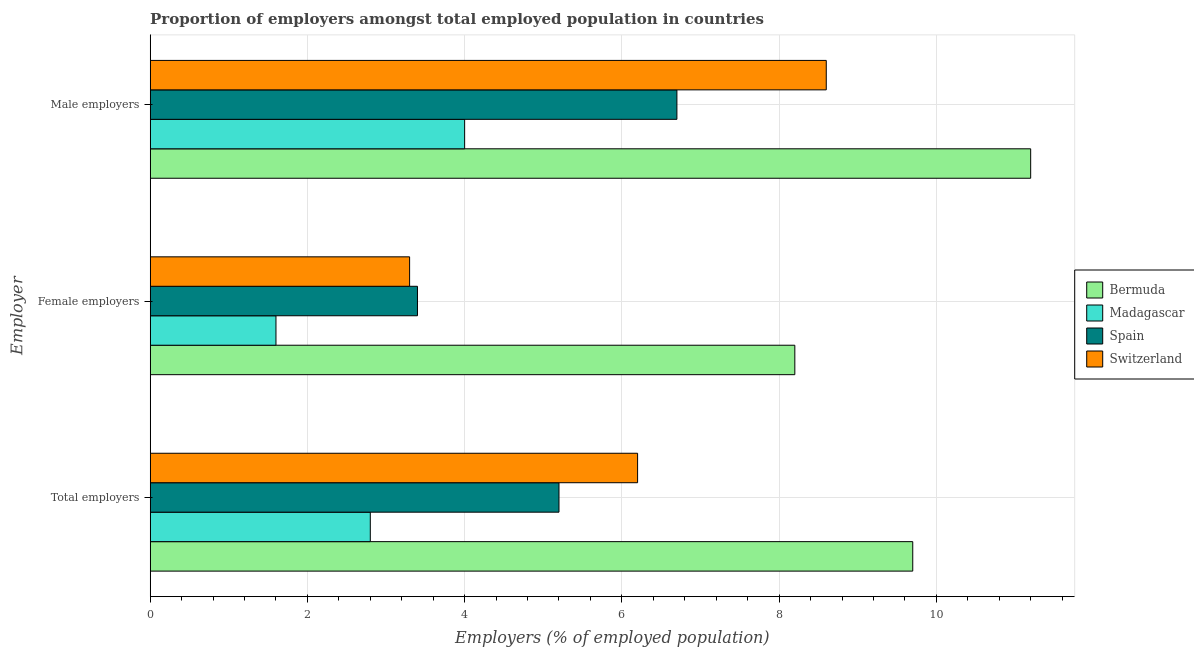How many different coloured bars are there?
Offer a very short reply. 4. How many groups of bars are there?
Provide a short and direct response. 3. Are the number of bars per tick equal to the number of legend labels?
Offer a very short reply. Yes. What is the label of the 1st group of bars from the top?
Keep it short and to the point. Male employers. What is the percentage of female employers in Switzerland?
Make the answer very short. 3.3. Across all countries, what is the maximum percentage of total employers?
Keep it short and to the point. 9.7. In which country was the percentage of total employers maximum?
Offer a very short reply. Bermuda. In which country was the percentage of total employers minimum?
Ensure brevity in your answer.  Madagascar. What is the total percentage of total employers in the graph?
Keep it short and to the point. 23.9. What is the difference between the percentage of male employers in Madagascar and that in Spain?
Keep it short and to the point. -2.7. What is the difference between the percentage of female employers in Bermuda and the percentage of male employers in Spain?
Offer a terse response. 1.5. What is the average percentage of female employers per country?
Your answer should be compact. 4.12. What is the difference between the percentage of female employers and percentage of male employers in Spain?
Ensure brevity in your answer.  -3.3. In how many countries, is the percentage of total employers greater than 4 %?
Keep it short and to the point. 3. What is the ratio of the percentage of total employers in Bermuda to that in Spain?
Make the answer very short. 1.87. Is the difference between the percentage of female employers in Switzerland and Madagascar greater than the difference between the percentage of total employers in Switzerland and Madagascar?
Offer a very short reply. No. What is the difference between the highest and the second highest percentage of female employers?
Your answer should be compact. 4.8. What is the difference between the highest and the lowest percentage of male employers?
Make the answer very short. 7.2. Is the sum of the percentage of total employers in Spain and Madagascar greater than the maximum percentage of male employers across all countries?
Offer a very short reply. No. What does the 1st bar from the top in Male employers represents?
Your answer should be compact. Switzerland. What does the 4th bar from the bottom in Male employers represents?
Offer a very short reply. Switzerland. How many bars are there?
Your response must be concise. 12. What is the difference between two consecutive major ticks on the X-axis?
Give a very brief answer. 2. Are the values on the major ticks of X-axis written in scientific E-notation?
Offer a terse response. No. Does the graph contain any zero values?
Give a very brief answer. No. Where does the legend appear in the graph?
Your answer should be compact. Center right. How many legend labels are there?
Provide a short and direct response. 4. How are the legend labels stacked?
Ensure brevity in your answer.  Vertical. What is the title of the graph?
Provide a short and direct response. Proportion of employers amongst total employed population in countries. Does "France" appear as one of the legend labels in the graph?
Offer a terse response. No. What is the label or title of the X-axis?
Provide a short and direct response. Employers (% of employed population). What is the label or title of the Y-axis?
Provide a succinct answer. Employer. What is the Employers (% of employed population) in Bermuda in Total employers?
Your response must be concise. 9.7. What is the Employers (% of employed population) in Madagascar in Total employers?
Your answer should be compact. 2.8. What is the Employers (% of employed population) in Spain in Total employers?
Your answer should be compact. 5.2. What is the Employers (% of employed population) of Switzerland in Total employers?
Provide a short and direct response. 6.2. What is the Employers (% of employed population) in Bermuda in Female employers?
Offer a very short reply. 8.2. What is the Employers (% of employed population) in Madagascar in Female employers?
Your response must be concise. 1.6. What is the Employers (% of employed population) of Spain in Female employers?
Provide a succinct answer. 3.4. What is the Employers (% of employed population) of Switzerland in Female employers?
Offer a terse response. 3.3. What is the Employers (% of employed population) of Bermuda in Male employers?
Make the answer very short. 11.2. What is the Employers (% of employed population) of Spain in Male employers?
Ensure brevity in your answer.  6.7. What is the Employers (% of employed population) of Switzerland in Male employers?
Your answer should be compact. 8.6. Across all Employer, what is the maximum Employers (% of employed population) of Bermuda?
Provide a short and direct response. 11.2. Across all Employer, what is the maximum Employers (% of employed population) of Spain?
Your answer should be very brief. 6.7. Across all Employer, what is the maximum Employers (% of employed population) in Switzerland?
Your answer should be compact. 8.6. Across all Employer, what is the minimum Employers (% of employed population) of Bermuda?
Offer a terse response. 8.2. Across all Employer, what is the minimum Employers (% of employed population) of Madagascar?
Your response must be concise. 1.6. Across all Employer, what is the minimum Employers (% of employed population) in Spain?
Ensure brevity in your answer.  3.4. Across all Employer, what is the minimum Employers (% of employed population) in Switzerland?
Ensure brevity in your answer.  3.3. What is the total Employers (% of employed population) of Bermuda in the graph?
Provide a short and direct response. 29.1. What is the total Employers (% of employed population) of Madagascar in the graph?
Provide a succinct answer. 8.4. What is the total Employers (% of employed population) of Spain in the graph?
Keep it short and to the point. 15.3. What is the difference between the Employers (% of employed population) in Madagascar in Total employers and that in Female employers?
Your answer should be compact. 1.2. What is the difference between the Employers (% of employed population) of Bermuda in Total employers and that in Male employers?
Give a very brief answer. -1.5. What is the difference between the Employers (% of employed population) of Spain in Total employers and that in Male employers?
Ensure brevity in your answer.  -1.5. What is the difference between the Employers (% of employed population) in Spain in Female employers and that in Male employers?
Provide a succinct answer. -3.3. What is the difference between the Employers (% of employed population) in Switzerland in Female employers and that in Male employers?
Provide a short and direct response. -5.3. What is the difference between the Employers (% of employed population) in Bermuda in Total employers and the Employers (% of employed population) in Spain in Female employers?
Provide a short and direct response. 6.3. What is the difference between the Employers (% of employed population) in Bermuda in Total employers and the Employers (% of employed population) in Switzerland in Female employers?
Keep it short and to the point. 6.4. What is the difference between the Employers (% of employed population) of Madagascar in Total employers and the Employers (% of employed population) of Spain in Female employers?
Your response must be concise. -0.6. What is the difference between the Employers (% of employed population) in Bermuda in Total employers and the Employers (% of employed population) in Spain in Male employers?
Your answer should be very brief. 3. What is the difference between the Employers (% of employed population) of Bermuda in Total employers and the Employers (% of employed population) of Switzerland in Male employers?
Your response must be concise. 1.1. What is the difference between the Employers (% of employed population) of Bermuda in Female employers and the Employers (% of employed population) of Spain in Male employers?
Provide a short and direct response. 1.5. What is the difference between the Employers (% of employed population) of Bermuda in Female employers and the Employers (% of employed population) of Switzerland in Male employers?
Offer a terse response. -0.4. What is the difference between the Employers (% of employed population) of Madagascar in Female employers and the Employers (% of employed population) of Switzerland in Male employers?
Provide a succinct answer. -7. What is the average Employers (% of employed population) of Madagascar per Employer?
Offer a very short reply. 2.8. What is the average Employers (% of employed population) in Spain per Employer?
Make the answer very short. 5.1. What is the average Employers (% of employed population) of Switzerland per Employer?
Make the answer very short. 6.03. What is the difference between the Employers (% of employed population) in Spain and Employers (% of employed population) in Switzerland in Total employers?
Provide a short and direct response. -1. What is the difference between the Employers (% of employed population) in Bermuda and Employers (% of employed population) in Switzerland in Female employers?
Offer a very short reply. 4.9. What is the difference between the Employers (% of employed population) of Spain and Employers (% of employed population) of Switzerland in Female employers?
Your answer should be very brief. 0.1. What is the difference between the Employers (% of employed population) in Bermuda and Employers (% of employed population) in Switzerland in Male employers?
Your response must be concise. 2.6. What is the difference between the Employers (% of employed population) in Madagascar and Employers (% of employed population) in Switzerland in Male employers?
Give a very brief answer. -4.6. What is the ratio of the Employers (% of employed population) in Bermuda in Total employers to that in Female employers?
Your answer should be compact. 1.18. What is the ratio of the Employers (% of employed population) in Madagascar in Total employers to that in Female employers?
Keep it short and to the point. 1.75. What is the ratio of the Employers (% of employed population) of Spain in Total employers to that in Female employers?
Give a very brief answer. 1.53. What is the ratio of the Employers (% of employed population) in Switzerland in Total employers to that in Female employers?
Offer a very short reply. 1.88. What is the ratio of the Employers (% of employed population) in Bermuda in Total employers to that in Male employers?
Your answer should be very brief. 0.87. What is the ratio of the Employers (% of employed population) of Spain in Total employers to that in Male employers?
Give a very brief answer. 0.78. What is the ratio of the Employers (% of employed population) in Switzerland in Total employers to that in Male employers?
Your answer should be very brief. 0.72. What is the ratio of the Employers (% of employed population) of Bermuda in Female employers to that in Male employers?
Provide a succinct answer. 0.73. What is the ratio of the Employers (% of employed population) of Spain in Female employers to that in Male employers?
Keep it short and to the point. 0.51. What is the ratio of the Employers (% of employed population) in Switzerland in Female employers to that in Male employers?
Offer a very short reply. 0.38. What is the difference between the highest and the second highest Employers (% of employed population) in Spain?
Offer a terse response. 1.5. What is the difference between the highest and the lowest Employers (% of employed population) of Spain?
Give a very brief answer. 3.3. What is the difference between the highest and the lowest Employers (% of employed population) of Switzerland?
Make the answer very short. 5.3. 